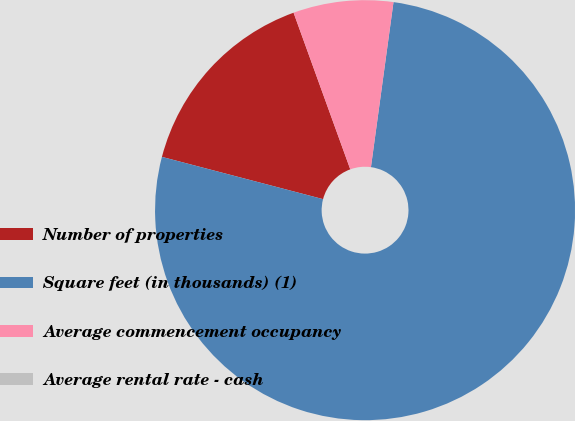<chart> <loc_0><loc_0><loc_500><loc_500><pie_chart><fcel>Number of properties<fcel>Square feet (in thousands) (1)<fcel>Average commencement occupancy<fcel>Average rental rate - cash<nl><fcel>15.39%<fcel>76.92%<fcel>7.69%<fcel>0.0%<nl></chart> 